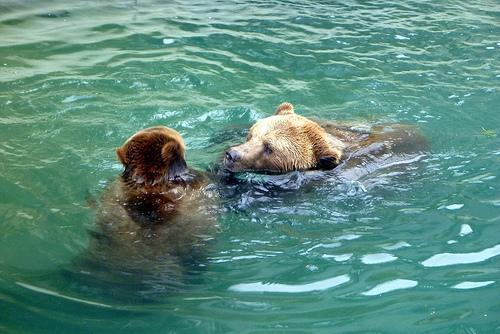How many animals are there?
Give a very brief answer. 2. 